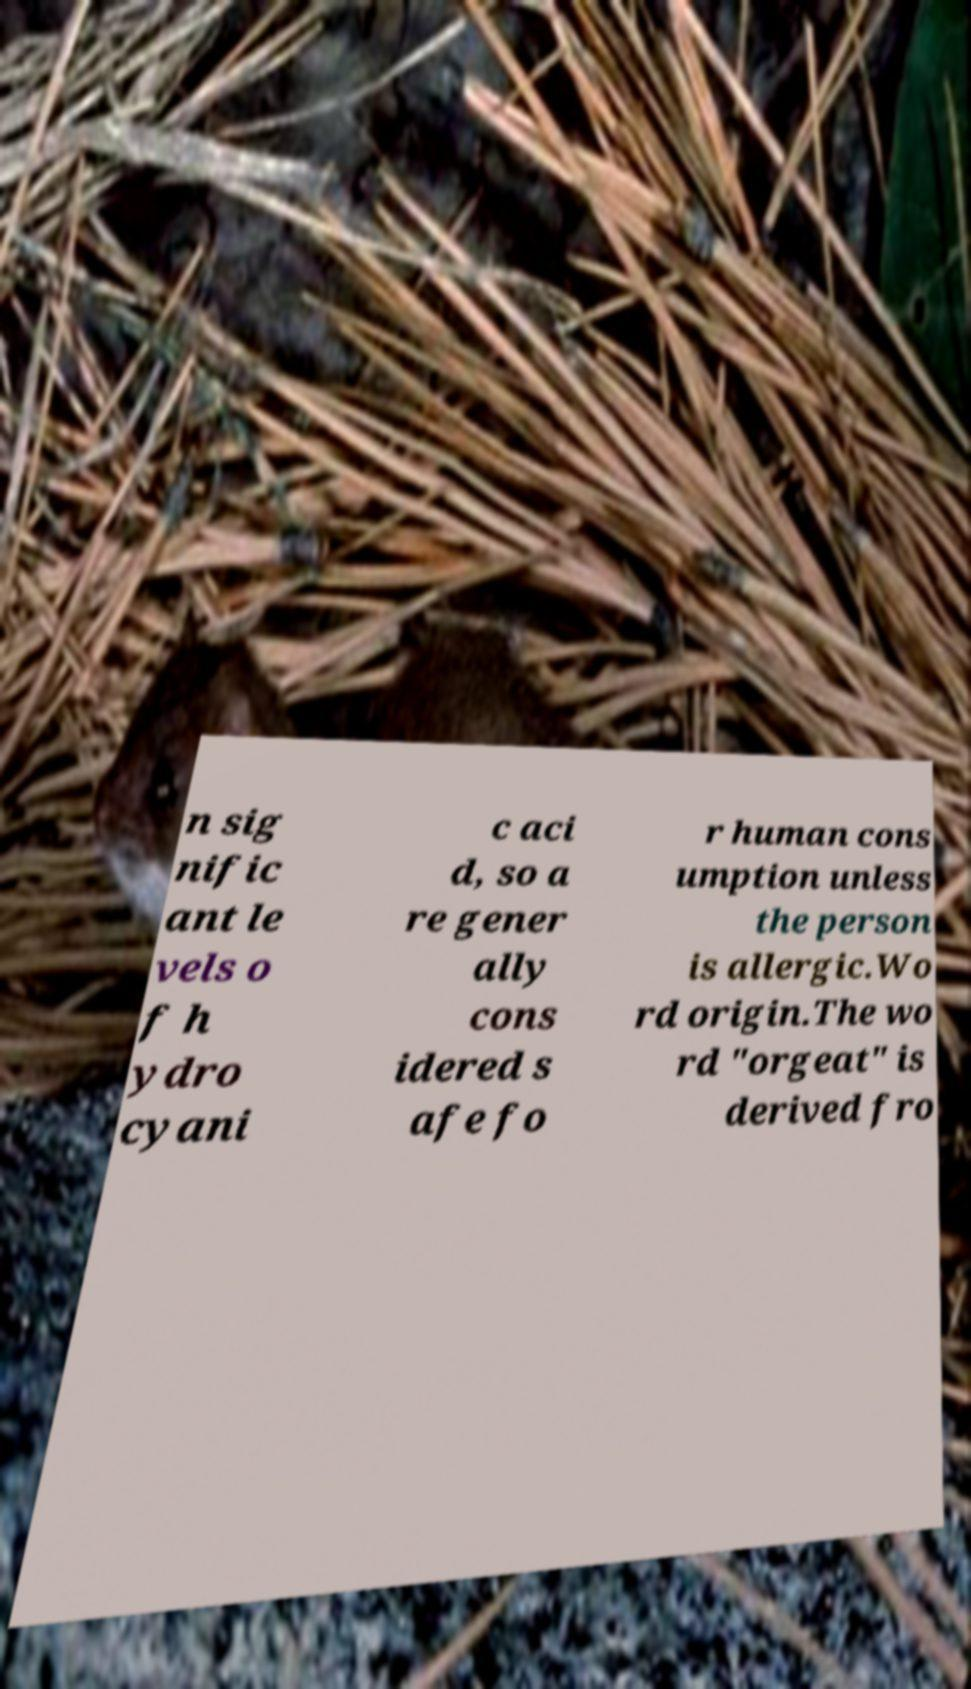Can you accurately transcribe the text from the provided image for me? n sig nific ant le vels o f h ydro cyani c aci d, so a re gener ally cons idered s afe fo r human cons umption unless the person is allergic.Wo rd origin.The wo rd "orgeat" is derived fro 